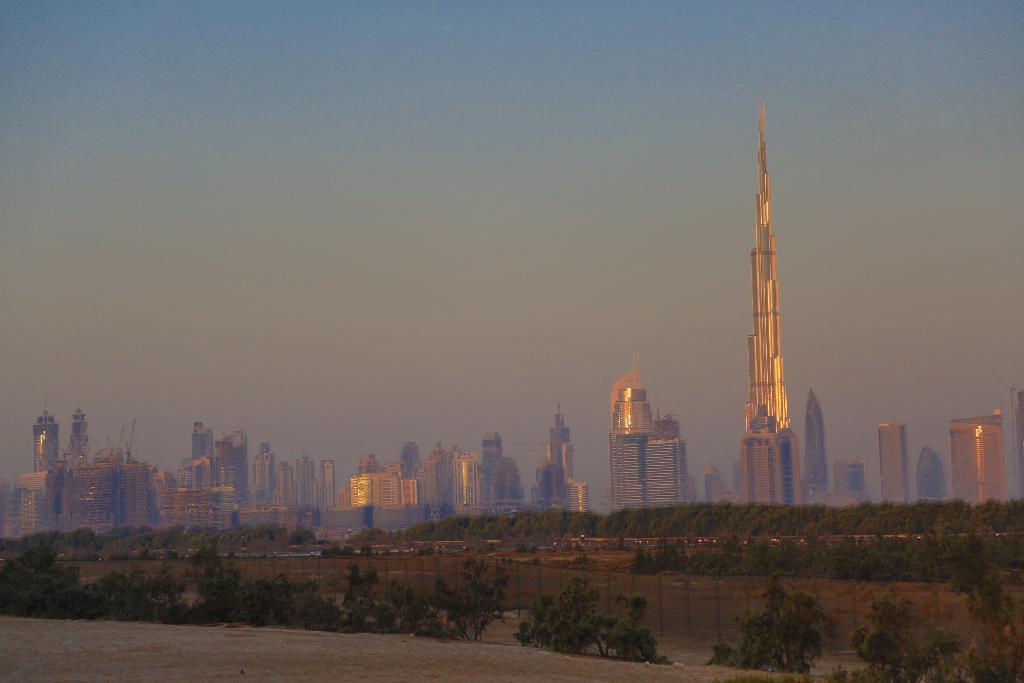In one or two sentences, can you explain what this image depicts? In this image, we can see some buildings, there are some plants, at the top there is a sky which is cloudy. 